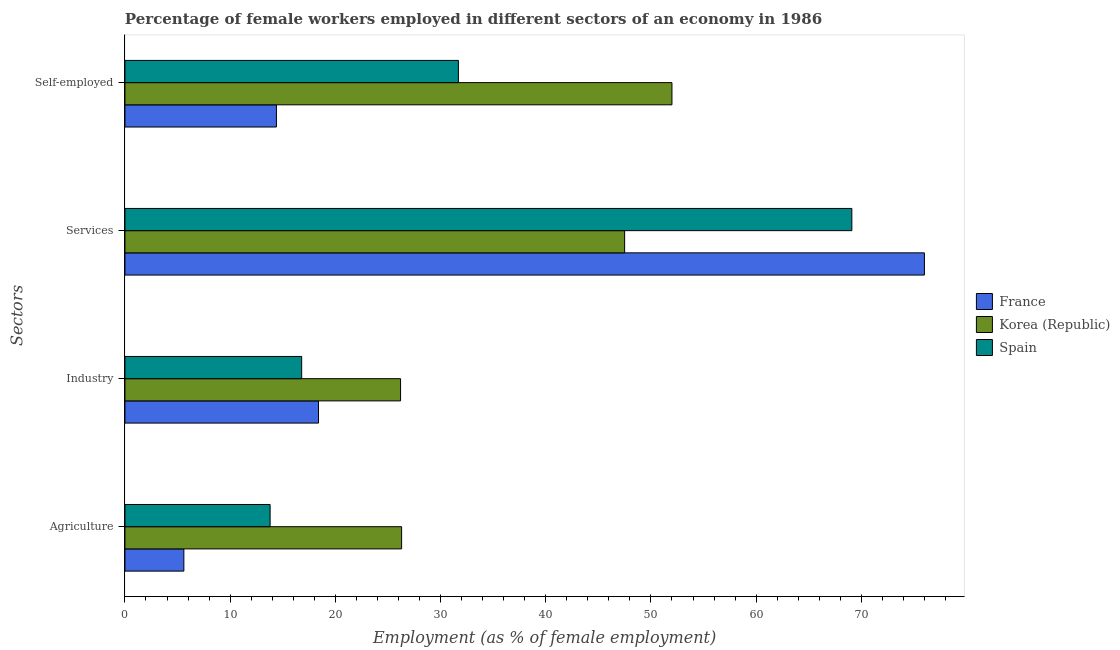How many groups of bars are there?
Offer a terse response. 4. Are the number of bars on each tick of the Y-axis equal?
Offer a terse response. Yes. How many bars are there on the 2nd tick from the bottom?
Give a very brief answer. 3. What is the label of the 3rd group of bars from the top?
Keep it short and to the point. Industry. What is the percentage of female workers in services in Korea (Republic)?
Your answer should be compact. 47.5. Across all countries, what is the maximum percentage of female workers in agriculture?
Make the answer very short. 26.3. Across all countries, what is the minimum percentage of female workers in agriculture?
Make the answer very short. 5.6. What is the total percentage of female workers in services in the graph?
Give a very brief answer. 192.6. What is the difference between the percentage of female workers in industry in Spain and that in France?
Ensure brevity in your answer.  -1.6. What is the difference between the percentage of female workers in services in France and the percentage of female workers in industry in Spain?
Ensure brevity in your answer.  59.2. What is the average percentage of female workers in services per country?
Provide a succinct answer. 64.2. In how many countries, is the percentage of self employed female workers greater than 8 %?
Offer a very short reply. 3. What is the ratio of the percentage of female workers in agriculture in France to that in Spain?
Make the answer very short. 0.41. Is the difference between the percentage of self employed female workers in France and Korea (Republic) greater than the difference between the percentage of female workers in agriculture in France and Korea (Republic)?
Your answer should be compact. No. What is the difference between the highest and the second highest percentage of female workers in industry?
Keep it short and to the point. 7.8. What is the difference between the highest and the lowest percentage of self employed female workers?
Offer a terse response. 37.6. In how many countries, is the percentage of female workers in agriculture greater than the average percentage of female workers in agriculture taken over all countries?
Keep it short and to the point. 1. Is the sum of the percentage of female workers in industry in Korea (Republic) and Spain greater than the maximum percentage of self employed female workers across all countries?
Offer a very short reply. No. Is it the case that in every country, the sum of the percentage of female workers in agriculture and percentage of female workers in industry is greater than the sum of percentage of self employed female workers and percentage of female workers in services?
Provide a short and direct response. No. What does the 3rd bar from the top in Self-employed represents?
Offer a terse response. France. Is it the case that in every country, the sum of the percentage of female workers in agriculture and percentage of female workers in industry is greater than the percentage of female workers in services?
Your answer should be compact. No. How many bars are there?
Offer a very short reply. 12. How many countries are there in the graph?
Provide a succinct answer. 3. What is the difference between two consecutive major ticks on the X-axis?
Provide a succinct answer. 10. Are the values on the major ticks of X-axis written in scientific E-notation?
Make the answer very short. No. Does the graph contain any zero values?
Ensure brevity in your answer.  No. Does the graph contain grids?
Offer a terse response. No. Where does the legend appear in the graph?
Keep it short and to the point. Center right. How many legend labels are there?
Ensure brevity in your answer.  3. How are the legend labels stacked?
Ensure brevity in your answer.  Vertical. What is the title of the graph?
Give a very brief answer. Percentage of female workers employed in different sectors of an economy in 1986. What is the label or title of the X-axis?
Give a very brief answer. Employment (as % of female employment). What is the label or title of the Y-axis?
Provide a succinct answer. Sectors. What is the Employment (as % of female employment) of France in Agriculture?
Your answer should be compact. 5.6. What is the Employment (as % of female employment) of Korea (Republic) in Agriculture?
Provide a short and direct response. 26.3. What is the Employment (as % of female employment) of Spain in Agriculture?
Ensure brevity in your answer.  13.8. What is the Employment (as % of female employment) of France in Industry?
Give a very brief answer. 18.4. What is the Employment (as % of female employment) of Korea (Republic) in Industry?
Your answer should be compact. 26.2. What is the Employment (as % of female employment) of Spain in Industry?
Offer a terse response. 16.8. What is the Employment (as % of female employment) of France in Services?
Your answer should be compact. 76. What is the Employment (as % of female employment) in Korea (Republic) in Services?
Your answer should be very brief. 47.5. What is the Employment (as % of female employment) in Spain in Services?
Your answer should be very brief. 69.1. What is the Employment (as % of female employment) of France in Self-employed?
Provide a short and direct response. 14.4. What is the Employment (as % of female employment) of Spain in Self-employed?
Your answer should be compact. 31.7. Across all Sectors, what is the maximum Employment (as % of female employment) in France?
Keep it short and to the point. 76. Across all Sectors, what is the maximum Employment (as % of female employment) in Spain?
Your response must be concise. 69.1. Across all Sectors, what is the minimum Employment (as % of female employment) of France?
Your response must be concise. 5.6. Across all Sectors, what is the minimum Employment (as % of female employment) in Korea (Republic)?
Your response must be concise. 26.2. Across all Sectors, what is the minimum Employment (as % of female employment) in Spain?
Make the answer very short. 13.8. What is the total Employment (as % of female employment) in France in the graph?
Ensure brevity in your answer.  114.4. What is the total Employment (as % of female employment) of Korea (Republic) in the graph?
Make the answer very short. 152. What is the total Employment (as % of female employment) in Spain in the graph?
Give a very brief answer. 131.4. What is the difference between the Employment (as % of female employment) of Korea (Republic) in Agriculture and that in Industry?
Give a very brief answer. 0.1. What is the difference between the Employment (as % of female employment) in France in Agriculture and that in Services?
Offer a very short reply. -70.4. What is the difference between the Employment (as % of female employment) in Korea (Republic) in Agriculture and that in Services?
Your answer should be compact. -21.2. What is the difference between the Employment (as % of female employment) of Spain in Agriculture and that in Services?
Your answer should be compact. -55.3. What is the difference between the Employment (as % of female employment) of Korea (Republic) in Agriculture and that in Self-employed?
Keep it short and to the point. -25.7. What is the difference between the Employment (as % of female employment) in Spain in Agriculture and that in Self-employed?
Give a very brief answer. -17.9. What is the difference between the Employment (as % of female employment) of France in Industry and that in Services?
Give a very brief answer. -57.6. What is the difference between the Employment (as % of female employment) of Korea (Republic) in Industry and that in Services?
Offer a terse response. -21.3. What is the difference between the Employment (as % of female employment) in Spain in Industry and that in Services?
Offer a terse response. -52.3. What is the difference between the Employment (as % of female employment) of Korea (Republic) in Industry and that in Self-employed?
Keep it short and to the point. -25.8. What is the difference between the Employment (as % of female employment) in Spain in Industry and that in Self-employed?
Offer a terse response. -14.9. What is the difference between the Employment (as % of female employment) of France in Services and that in Self-employed?
Your answer should be compact. 61.6. What is the difference between the Employment (as % of female employment) in Korea (Republic) in Services and that in Self-employed?
Offer a terse response. -4.5. What is the difference between the Employment (as % of female employment) in Spain in Services and that in Self-employed?
Your response must be concise. 37.4. What is the difference between the Employment (as % of female employment) of France in Agriculture and the Employment (as % of female employment) of Korea (Republic) in Industry?
Offer a terse response. -20.6. What is the difference between the Employment (as % of female employment) in France in Agriculture and the Employment (as % of female employment) in Korea (Republic) in Services?
Your answer should be very brief. -41.9. What is the difference between the Employment (as % of female employment) in France in Agriculture and the Employment (as % of female employment) in Spain in Services?
Provide a short and direct response. -63.5. What is the difference between the Employment (as % of female employment) in Korea (Republic) in Agriculture and the Employment (as % of female employment) in Spain in Services?
Provide a short and direct response. -42.8. What is the difference between the Employment (as % of female employment) in France in Agriculture and the Employment (as % of female employment) in Korea (Republic) in Self-employed?
Provide a short and direct response. -46.4. What is the difference between the Employment (as % of female employment) in France in Agriculture and the Employment (as % of female employment) in Spain in Self-employed?
Keep it short and to the point. -26.1. What is the difference between the Employment (as % of female employment) of Korea (Republic) in Agriculture and the Employment (as % of female employment) of Spain in Self-employed?
Your answer should be compact. -5.4. What is the difference between the Employment (as % of female employment) in France in Industry and the Employment (as % of female employment) in Korea (Republic) in Services?
Offer a terse response. -29.1. What is the difference between the Employment (as % of female employment) in France in Industry and the Employment (as % of female employment) in Spain in Services?
Your response must be concise. -50.7. What is the difference between the Employment (as % of female employment) of Korea (Republic) in Industry and the Employment (as % of female employment) of Spain in Services?
Offer a very short reply. -42.9. What is the difference between the Employment (as % of female employment) in France in Industry and the Employment (as % of female employment) in Korea (Republic) in Self-employed?
Offer a very short reply. -33.6. What is the difference between the Employment (as % of female employment) in France in Services and the Employment (as % of female employment) in Spain in Self-employed?
Make the answer very short. 44.3. What is the difference between the Employment (as % of female employment) in Korea (Republic) in Services and the Employment (as % of female employment) in Spain in Self-employed?
Offer a terse response. 15.8. What is the average Employment (as % of female employment) in France per Sectors?
Provide a short and direct response. 28.6. What is the average Employment (as % of female employment) in Korea (Republic) per Sectors?
Provide a succinct answer. 38. What is the average Employment (as % of female employment) of Spain per Sectors?
Your answer should be compact. 32.85. What is the difference between the Employment (as % of female employment) of France and Employment (as % of female employment) of Korea (Republic) in Agriculture?
Provide a succinct answer. -20.7. What is the difference between the Employment (as % of female employment) in Korea (Republic) and Employment (as % of female employment) in Spain in Agriculture?
Provide a short and direct response. 12.5. What is the difference between the Employment (as % of female employment) of France and Employment (as % of female employment) of Spain in Industry?
Offer a very short reply. 1.6. What is the difference between the Employment (as % of female employment) in Korea (Republic) and Employment (as % of female employment) in Spain in Industry?
Your answer should be compact. 9.4. What is the difference between the Employment (as % of female employment) of France and Employment (as % of female employment) of Spain in Services?
Provide a short and direct response. 6.9. What is the difference between the Employment (as % of female employment) of Korea (Republic) and Employment (as % of female employment) of Spain in Services?
Provide a short and direct response. -21.6. What is the difference between the Employment (as % of female employment) of France and Employment (as % of female employment) of Korea (Republic) in Self-employed?
Your answer should be very brief. -37.6. What is the difference between the Employment (as % of female employment) of France and Employment (as % of female employment) of Spain in Self-employed?
Make the answer very short. -17.3. What is the difference between the Employment (as % of female employment) of Korea (Republic) and Employment (as % of female employment) of Spain in Self-employed?
Ensure brevity in your answer.  20.3. What is the ratio of the Employment (as % of female employment) of France in Agriculture to that in Industry?
Ensure brevity in your answer.  0.3. What is the ratio of the Employment (as % of female employment) of Spain in Agriculture to that in Industry?
Give a very brief answer. 0.82. What is the ratio of the Employment (as % of female employment) in France in Agriculture to that in Services?
Ensure brevity in your answer.  0.07. What is the ratio of the Employment (as % of female employment) of Korea (Republic) in Agriculture to that in Services?
Provide a succinct answer. 0.55. What is the ratio of the Employment (as % of female employment) in Spain in Agriculture to that in Services?
Your answer should be very brief. 0.2. What is the ratio of the Employment (as % of female employment) in France in Agriculture to that in Self-employed?
Keep it short and to the point. 0.39. What is the ratio of the Employment (as % of female employment) in Korea (Republic) in Agriculture to that in Self-employed?
Keep it short and to the point. 0.51. What is the ratio of the Employment (as % of female employment) of Spain in Agriculture to that in Self-employed?
Offer a very short reply. 0.44. What is the ratio of the Employment (as % of female employment) of France in Industry to that in Services?
Offer a terse response. 0.24. What is the ratio of the Employment (as % of female employment) in Korea (Republic) in Industry to that in Services?
Provide a short and direct response. 0.55. What is the ratio of the Employment (as % of female employment) of Spain in Industry to that in Services?
Your answer should be very brief. 0.24. What is the ratio of the Employment (as % of female employment) of France in Industry to that in Self-employed?
Keep it short and to the point. 1.28. What is the ratio of the Employment (as % of female employment) of Korea (Republic) in Industry to that in Self-employed?
Provide a short and direct response. 0.5. What is the ratio of the Employment (as % of female employment) of Spain in Industry to that in Self-employed?
Ensure brevity in your answer.  0.53. What is the ratio of the Employment (as % of female employment) of France in Services to that in Self-employed?
Keep it short and to the point. 5.28. What is the ratio of the Employment (as % of female employment) in Korea (Republic) in Services to that in Self-employed?
Keep it short and to the point. 0.91. What is the ratio of the Employment (as % of female employment) of Spain in Services to that in Self-employed?
Keep it short and to the point. 2.18. What is the difference between the highest and the second highest Employment (as % of female employment) of France?
Your answer should be very brief. 57.6. What is the difference between the highest and the second highest Employment (as % of female employment) in Spain?
Your answer should be very brief. 37.4. What is the difference between the highest and the lowest Employment (as % of female employment) in France?
Your answer should be compact. 70.4. What is the difference between the highest and the lowest Employment (as % of female employment) of Korea (Republic)?
Provide a short and direct response. 25.8. What is the difference between the highest and the lowest Employment (as % of female employment) in Spain?
Your answer should be very brief. 55.3. 